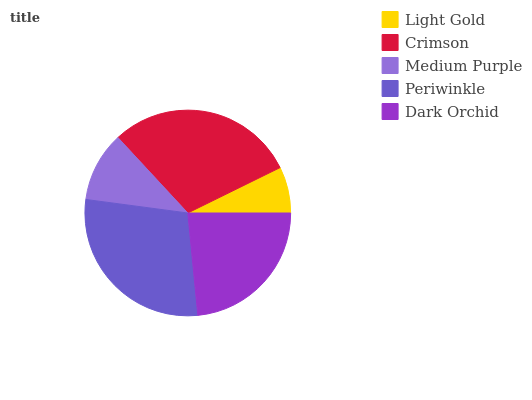Is Light Gold the minimum?
Answer yes or no. Yes. Is Crimson the maximum?
Answer yes or no. Yes. Is Medium Purple the minimum?
Answer yes or no. No. Is Medium Purple the maximum?
Answer yes or no. No. Is Crimson greater than Medium Purple?
Answer yes or no. Yes. Is Medium Purple less than Crimson?
Answer yes or no. Yes. Is Medium Purple greater than Crimson?
Answer yes or no. No. Is Crimson less than Medium Purple?
Answer yes or no. No. Is Dark Orchid the high median?
Answer yes or no. Yes. Is Dark Orchid the low median?
Answer yes or no. Yes. Is Light Gold the high median?
Answer yes or no. No. Is Light Gold the low median?
Answer yes or no. No. 